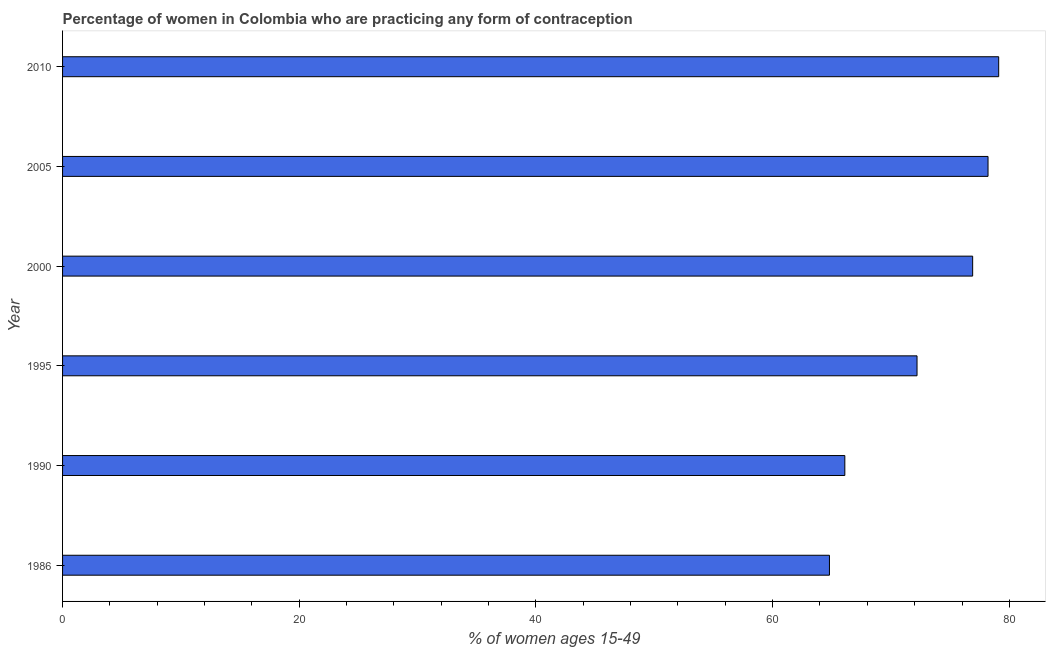Does the graph contain any zero values?
Keep it short and to the point. No. Does the graph contain grids?
Your answer should be very brief. No. What is the title of the graph?
Give a very brief answer. Percentage of women in Colombia who are practicing any form of contraception. What is the label or title of the X-axis?
Your answer should be very brief. % of women ages 15-49. What is the contraceptive prevalence in 1990?
Provide a short and direct response. 66.1. Across all years, what is the maximum contraceptive prevalence?
Provide a short and direct response. 79.1. Across all years, what is the minimum contraceptive prevalence?
Your answer should be very brief. 64.8. In which year was the contraceptive prevalence minimum?
Keep it short and to the point. 1986. What is the sum of the contraceptive prevalence?
Provide a succinct answer. 437.3. What is the average contraceptive prevalence per year?
Offer a very short reply. 72.88. What is the median contraceptive prevalence?
Give a very brief answer. 74.55. In how many years, is the contraceptive prevalence greater than 56 %?
Provide a succinct answer. 6. What is the ratio of the contraceptive prevalence in 1986 to that in 2005?
Give a very brief answer. 0.83. How many bars are there?
Offer a terse response. 6. How many years are there in the graph?
Keep it short and to the point. 6. What is the % of women ages 15-49 in 1986?
Your response must be concise. 64.8. What is the % of women ages 15-49 of 1990?
Provide a succinct answer. 66.1. What is the % of women ages 15-49 of 1995?
Your answer should be very brief. 72.2. What is the % of women ages 15-49 in 2000?
Keep it short and to the point. 76.9. What is the % of women ages 15-49 in 2005?
Your answer should be very brief. 78.2. What is the % of women ages 15-49 of 2010?
Ensure brevity in your answer.  79.1. What is the difference between the % of women ages 15-49 in 1986 and 2005?
Offer a very short reply. -13.4. What is the difference between the % of women ages 15-49 in 1986 and 2010?
Provide a succinct answer. -14.3. What is the difference between the % of women ages 15-49 in 1990 and 2000?
Offer a terse response. -10.8. What is the difference between the % of women ages 15-49 in 1990 and 2005?
Give a very brief answer. -12.1. What is the difference between the % of women ages 15-49 in 1995 and 2000?
Offer a terse response. -4.7. What is the difference between the % of women ages 15-49 in 1995 and 2005?
Your answer should be compact. -6. What is the difference between the % of women ages 15-49 in 1995 and 2010?
Make the answer very short. -6.9. What is the difference between the % of women ages 15-49 in 2000 and 2005?
Provide a short and direct response. -1.3. What is the ratio of the % of women ages 15-49 in 1986 to that in 1995?
Offer a very short reply. 0.9. What is the ratio of the % of women ages 15-49 in 1986 to that in 2000?
Provide a short and direct response. 0.84. What is the ratio of the % of women ages 15-49 in 1986 to that in 2005?
Provide a short and direct response. 0.83. What is the ratio of the % of women ages 15-49 in 1986 to that in 2010?
Provide a succinct answer. 0.82. What is the ratio of the % of women ages 15-49 in 1990 to that in 1995?
Make the answer very short. 0.92. What is the ratio of the % of women ages 15-49 in 1990 to that in 2000?
Provide a short and direct response. 0.86. What is the ratio of the % of women ages 15-49 in 1990 to that in 2005?
Ensure brevity in your answer.  0.84. What is the ratio of the % of women ages 15-49 in 1990 to that in 2010?
Provide a short and direct response. 0.84. What is the ratio of the % of women ages 15-49 in 1995 to that in 2000?
Keep it short and to the point. 0.94. What is the ratio of the % of women ages 15-49 in 1995 to that in 2005?
Offer a terse response. 0.92. What is the ratio of the % of women ages 15-49 in 1995 to that in 2010?
Provide a short and direct response. 0.91. 